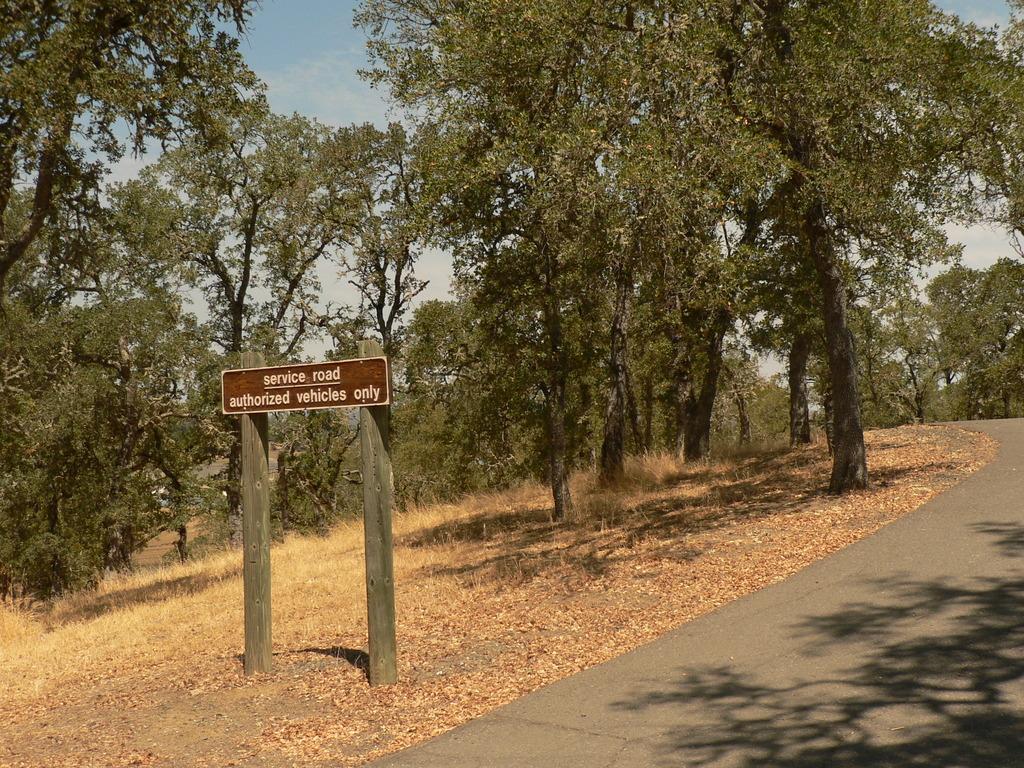Could you give a brief overview of what you see in this image? At the bottom of the picture, we see the road. Beside that, we see dried leaves, twigs and dry grass. In the middle of the picture, we see a brown board with some text written on it. There are many trees in the background. At the top of the picture, we see the sky. 